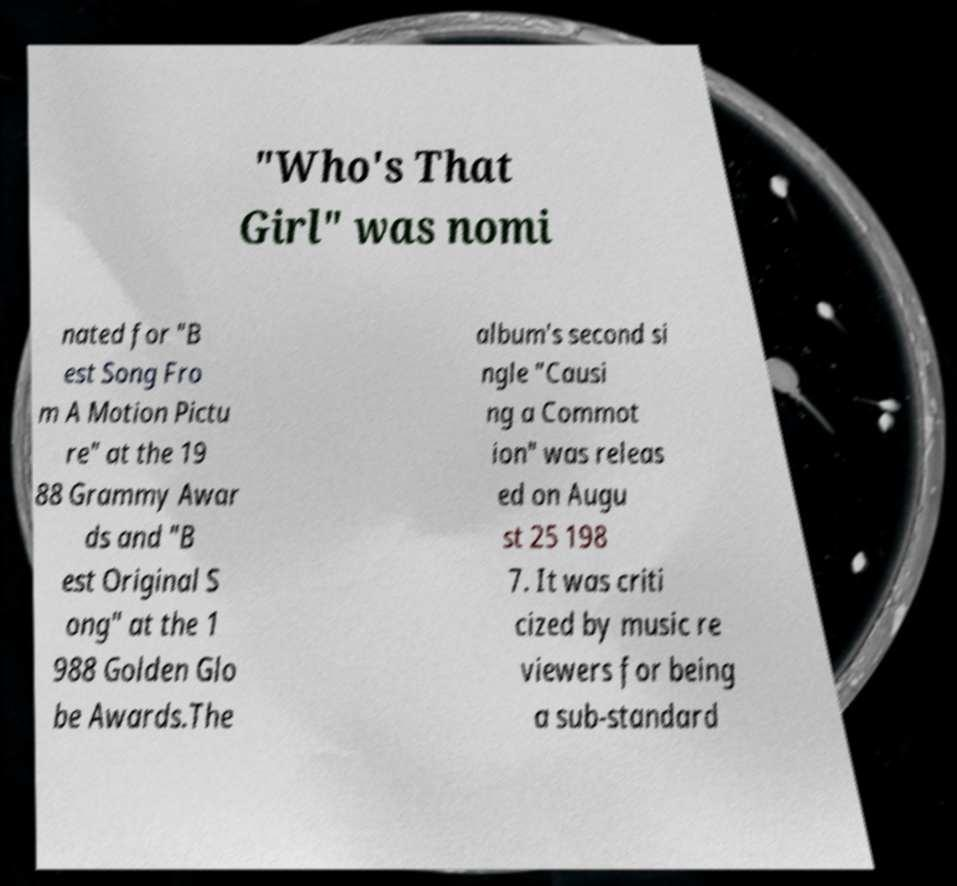Could you extract and type out the text from this image? "Who's That Girl" was nomi nated for "B est Song Fro m A Motion Pictu re" at the 19 88 Grammy Awar ds and "B est Original S ong" at the 1 988 Golden Glo be Awards.The album's second si ngle "Causi ng a Commot ion" was releas ed on Augu st 25 198 7. It was criti cized by music re viewers for being a sub-standard 